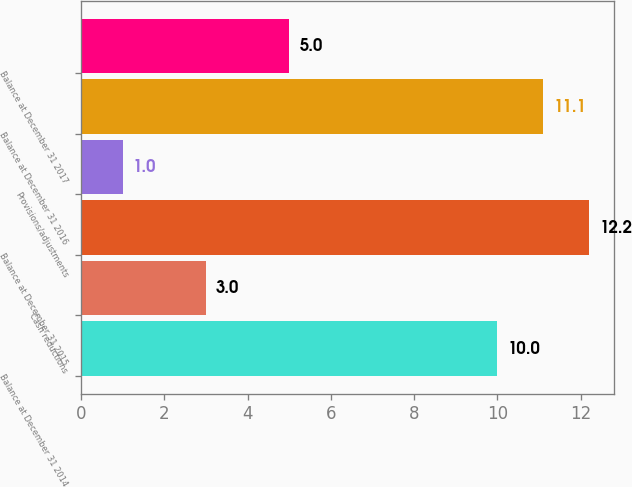Convert chart. <chart><loc_0><loc_0><loc_500><loc_500><bar_chart><fcel>Balance at December 31 2014<fcel>Cash reductions<fcel>Balance at December 31 2015<fcel>Provisions/adjustments<fcel>Balance at December 31 2016<fcel>Balance at December 31 2017<nl><fcel>10<fcel>3<fcel>12.2<fcel>1<fcel>11.1<fcel>5<nl></chart> 